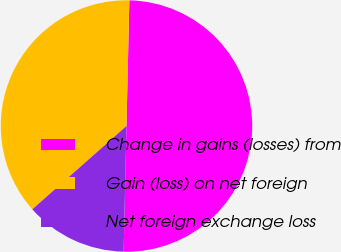<chart> <loc_0><loc_0><loc_500><loc_500><pie_chart><fcel>Change in gains (losses) from<fcel>Gain (loss) on net foreign<fcel>Net foreign exchange loss<nl><fcel>50.0%<fcel>36.89%<fcel>13.11%<nl></chart> 